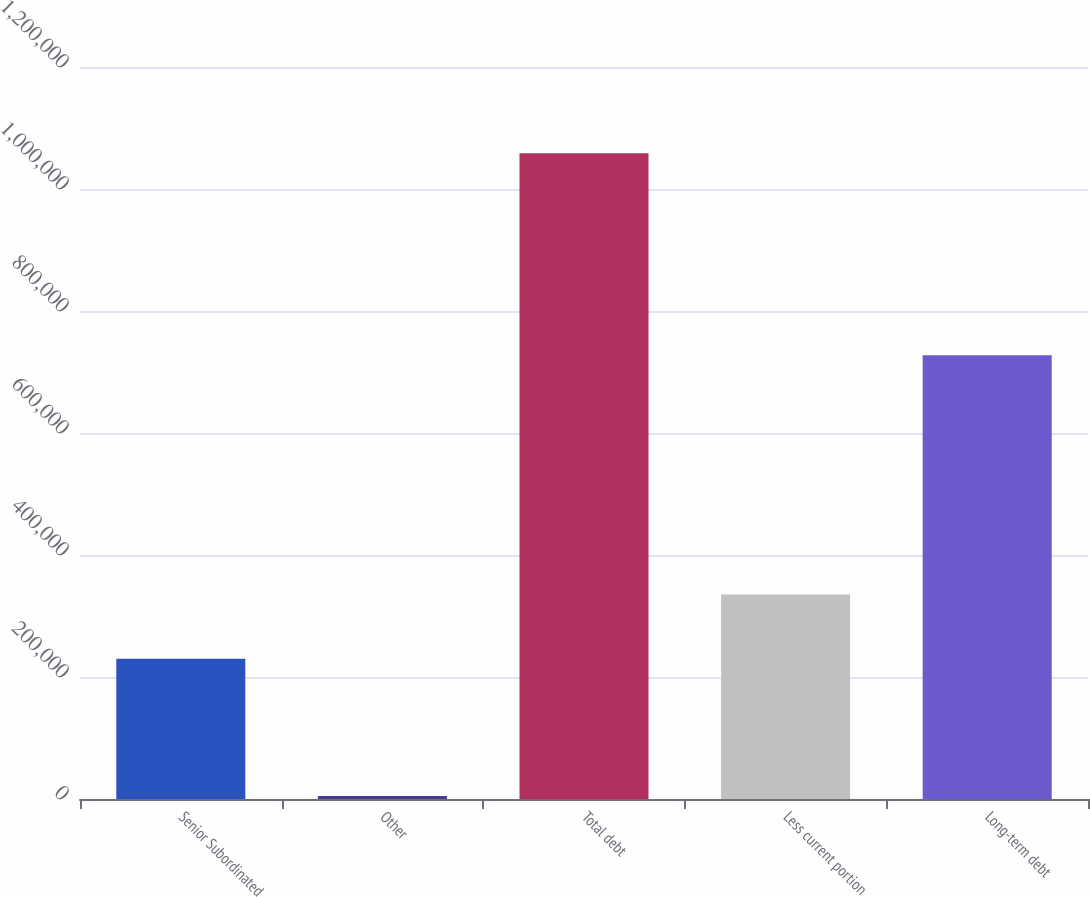Convert chart to OTSL. <chart><loc_0><loc_0><loc_500><loc_500><bar_chart><fcel>Senior Subordinated<fcel>Other<fcel>Total debt<fcel>Less current portion<fcel>Long-term debt<nl><fcel>230000<fcel>4847<fcel>1.05859e+06<fcel>335374<fcel>727489<nl></chart> 